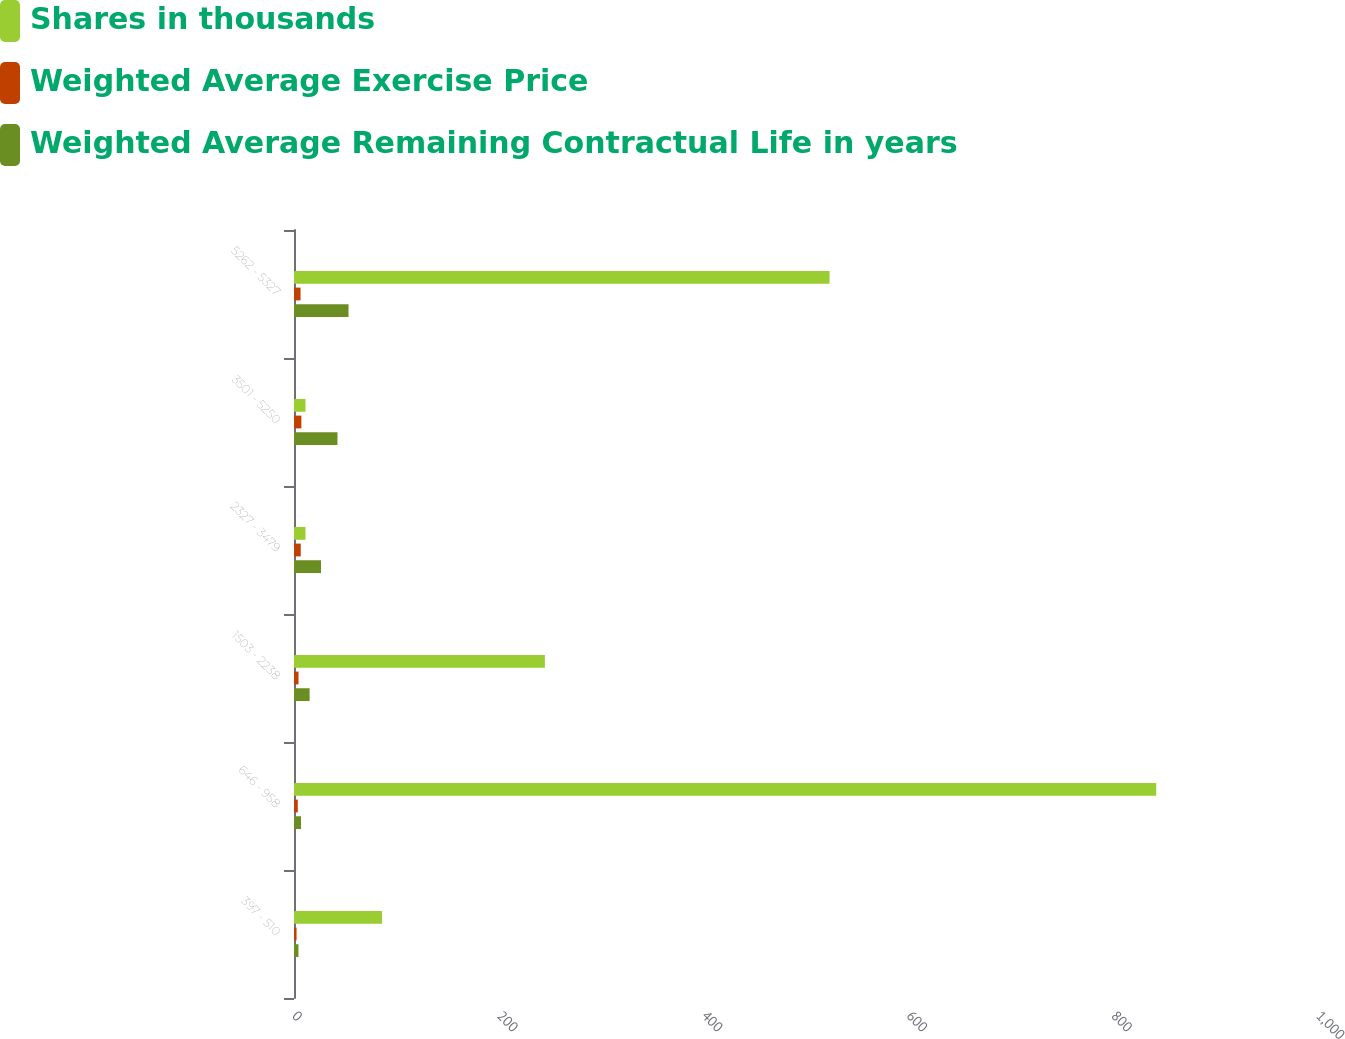Convert chart to OTSL. <chart><loc_0><loc_0><loc_500><loc_500><stacked_bar_chart><ecel><fcel>397 - 510<fcel>646 - 958<fcel>1503 - 2238<fcel>2327 - 3479<fcel>3501 - 5250<fcel>5262 - 5327<nl><fcel>Shares in thousands<fcel>86<fcel>842<fcel>245<fcel>11.23<fcel>11.23<fcel>523<nl><fcel>Weighted Average Exercise Price<fcel>2.5<fcel>3.7<fcel>4.4<fcel>6.6<fcel>7.2<fcel>6.4<nl><fcel>Weighted Average Remaining Contractual Life in years<fcel>4.36<fcel>6.84<fcel>15.26<fcel>26.35<fcel>42.45<fcel>53.25<nl></chart> 